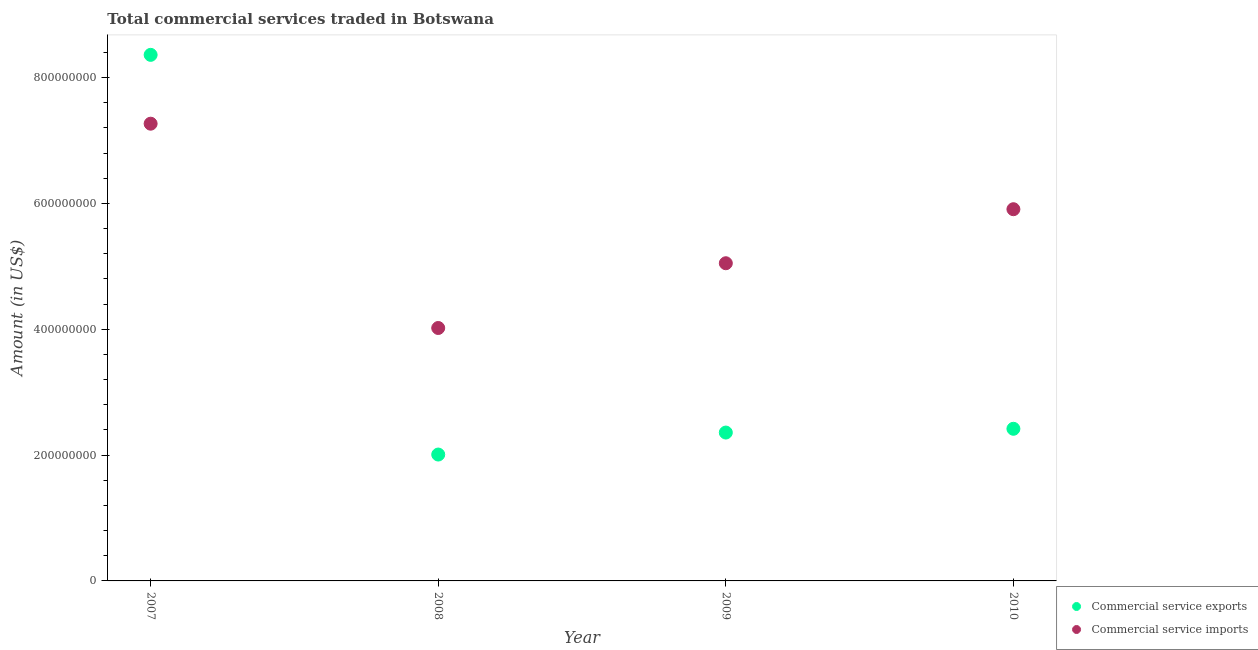What is the amount of commercial service exports in 2008?
Provide a succinct answer. 2.01e+08. Across all years, what is the maximum amount of commercial service exports?
Your answer should be very brief. 8.36e+08. Across all years, what is the minimum amount of commercial service exports?
Ensure brevity in your answer.  2.01e+08. In which year was the amount of commercial service exports minimum?
Provide a short and direct response. 2008. What is the total amount of commercial service imports in the graph?
Provide a short and direct response. 2.22e+09. What is the difference between the amount of commercial service imports in 2007 and that in 2009?
Offer a terse response. 2.22e+08. What is the difference between the amount of commercial service imports in 2010 and the amount of commercial service exports in 2008?
Provide a succinct answer. 3.90e+08. What is the average amount of commercial service exports per year?
Give a very brief answer. 3.79e+08. In the year 2007, what is the difference between the amount of commercial service exports and amount of commercial service imports?
Give a very brief answer. 1.09e+08. What is the ratio of the amount of commercial service exports in 2008 to that in 2009?
Provide a succinct answer. 0.85. Is the difference between the amount of commercial service imports in 2009 and 2010 greater than the difference between the amount of commercial service exports in 2009 and 2010?
Provide a short and direct response. No. What is the difference between the highest and the second highest amount of commercial service imports?
Provide a short and direct response. 1.36e+08. What is the difference between the highest and the lowest amount of commercial service imports?
Keep it short and to the point. 3.25e+08. Is the amount of commercial service exports strictly greater than the amount of commercial service imports over the years?
Your answer should be very brief. No. How many dotlines are there?
Give a very brief answer. 2. How many years are there in the graph?
Provide a succinct answer. 4. What is the difference between two consecutive major ticks on the Y-axis?
Your answer should be very brief. 2.00e+08. Does the graph contain any zero values?
Provide a succinct answer. No. What is the title of the graph?
Your answer should be compact. Total commercial services traded in Botswana. Does "Register a business" appear as one of the legend labels in the graph?
Provide a succinct answer. No. What is the label or title of the Y-axis?
Ensure brevity in your answer.  Amount (in US$). What is the Amount (in US$) of Commercial service exports in 2007?
Provide a succinct answer. 8.36e+08. What is the Amount (in US$) in Commercial service imports in 2007?
Make the answer very short. 7.27e+08. What is the Amount (in US$) of Commercial service exports in 2008?
Make the answer very short. 2.01e+08. What is the Amount (in US$) in Commercial service imports in 2008?
Your response must be concise. 4.02e+08. What is the Amount (in US$) in Commercial service exports in 2009?
Provide a succinct answer. 2.36e+08. What is the Amount (in US$) in Commercial service imports in 2009?
Provide a succinct answer. 5.05e+08. What is the Amount (in US$) in Commercial service exports in 2010?
Your response must be concise. 2.42e+08. What is the Amount (in US$) in Commercial service imports in 2010?
Provide a short and direct response. 5.91e+08. Across all years, what is the maximum Amount (in US$) in Commercial service exports?
Give a very brief answer. 8.36e+08. Across all years, what is the maximum Amount (in US$) in Commercial service imports?
Your answer should be very brief. 7.27e+08. Across all years, what is the minimum Amount (in US$) of Commercial service exports?
Your answer should be very brief. 2.01e+08. Across all years, what is the minimum Amount (in US$) in Commercial service imports?
Ensure brevity in your answer.  4.02e+08. What is the total Amount (in US$) of Commercial service exports in the graph?
Provide a short and direct response. 1.51e+09. What is the total Amount (in US$) of Commercial service imports in the graph?
Provide a succinct answer. 2.22e+09. What is the difference between the Amount (in US$) in Commercial service exports in 2007 and that in 2008?
Offer a terse response. 6.35e+08. What is the difference between the Amount (in US$) in Commercial service imports in 2007 and that in 2008?
Keep it short and to the point. 3.25e+08. What is the difference between the Amount (in US$) in Commercial service exports in 2007 and that in 2009?
Offer a very short reply. 6.00e+08. What is the difference between the Amount (in US$) of Commercial service imports in 2007 and that in 2009?
Your answer should be very brief. 2.22e+08. What is the difference between the Amount (in US$) in Commercial service exports in 2007 and that in 2010?
Your answer should be compact. 5.94e+08. What is the difference between the Amount (in US$) of Commercial service imports in 2007 and that in 2010?
Provide a succinct answer. 1.36e+08. What is the difference between the Amount (in US$) in Commercial service exports in 2008 and that in 2009?
Provide a succinct answer. -3.49e+07. What is the difference between the Amount (in US$) in Commercial service imports in 2008 and that in 2009?
Offer a very short reply. -1.03e+08. What is the difference between the Amount (in US$) in Commercial service exports in 2008 and that in 2010?
Your response must be concise. -4.09e+07. What is the difference between the Amount (in US$) of Commercial service imports in 2008 and that in 2010?
Ensure brevity in your answer.  -1.89e+08. What is the difference between the Amount (in US$) in Commercial service exports in 2009 and that in 2010?
Provide a short and direct response. -6.00e+06. What is the difference between the Amount (in US$) in Commercial service imports in 2009 and that in 2010?
Give a very brief answer. -8.59e+07. What is the difference between the Amount (in US$) of Commercial service exports in 2007 and the Amount (in US$) of Commercial service imports in 2008?
Your answer should be very brief. 4.34e+08. What is the difference between the Amount (in US$) in Commercial service exports in 2007 and the Amount (in US$) in Commercial service imports in 2009?
Your answer should be very brief. 3.31e+08. What is the difference between the Amount (in US$) in Commercial service exports in 2007 and the Amount (in US$) in Commercial service imports in 2010?
Keep it short and to the point. 2.45e+08. What is the difference between the Amount (in US$) in Commercial service exports in 2008 and the Amount (in US$) in Commercial service imports in 2009?
Provide a succinct answer. -3.04e+08. What is the difference between the Amount (in US$) of Commercial service exports in 2008 and the Amount (in US$) of Commercial service imports in 2010?
Your response must be concise. -3.90e+08. What is the difference between the Amount (in US$) of Commercial service exports in 2009 and the Amount (in US$) of Commercial service imports in 2010?
Offer a terse response. -3.55e+08. What is the average Amount (in US$) of Commercial service exports per year?
Keep it short and to the point. 3.79e+08. What is the average Amount (in US$) of Commercial service imports per year?
Your answer should be very brief. 5.56e+08. In the year 2007, what is the difference between the Amount (in US$) of Commercial service exports and Amount (in US$) of Commercial service imports?
Your answer should be very brief. 1.09e+08. In the year 2008, what is the difference between the Amount (in US$) of Commercial service exports and Amount (in US$) of Commercial service imports?
Your answer should be very brief. -2.01e+08. In the year 2009, what is the difference between the Amount (in US$) of Commercial service exports and Amount (in US$) of Commercial service imports?
Your answer should be very brief. -2.69e+08. In the year 2010, what is the difference between the Amount (in US$) in Commercial service exports and Amount (in US$) in Commercial service imports?
Provide a short and direct response. -3.49e+08. What is the ratio of the Amount (in US$) in Commercial service exports in 2007 to that in 2008?
Give a very brief answer. 4.16. What is the ratio of the Amount (in US$) of Commercial service imports in 2007 to that in 2008?
Your answer should be compact. 1.81. What is the ratio of the Amount (in US$) of Commercial service exports in 2007 to that in 2009?
Give a very brief answer. 3.55. What is the ratio of the Amount (in US$) in Commercial service imports in 2007 to that in 2009?
Provide a succinct answer. 1.44. What is the ratio of the Amount (in US$) in Commercial service exports in 2007 to that in 2010?
Provide a succinct answer. 3.46. What is the ratio of the Amount (in US$) of Commercial service imports in 2007 to that in 2010?
Give a very brief answer. 1.23. What is the ratio of the Amount (in US$) of Commercial service exports in 2008 to that in 2009?
Offer a very short reply. 0.85. What is the ratio of the Amount (in US$) of Commercial service imports in 2008 to that in 2009?
Provide a succinct answer. 0.8. What is the ratio of the Amount (in US$) in Commercial service exports in 2008 to that in 2010?
Offer a very short reply. 0.83. What is the ratio of the Amount (in US$) of Commercial service imports in 2008 to that in 2010?
Offer a very short reply. 0.68. What is the ratio of the Amount (in US$) in Commercial service exports in 2009 to that in 2010?
Keep it short and to the point. 0.98. What is the ratio of the Amount (in US$) of Commercial service imports in 2009 to that in 2010?
Offer a terse response. 0.85. What is the difference between the highest and the second highest Amount (in US$) in Commercial service exports?
Offer a very short reply. 5.94e+08. What is the difference between the highest and the second highest Amount (in US$) of Commercial service imports?
Offer a very short reply. 1.36e+08. What is the difference between the highest and the lowest Amount (in US$) of Commercial service exports?
Your response must be concise. 6.35e+08. What is the difference between the highest and the lowest Amount (in US$) of Commercial service imports?
Make the answer very short. 3.25e+08. 